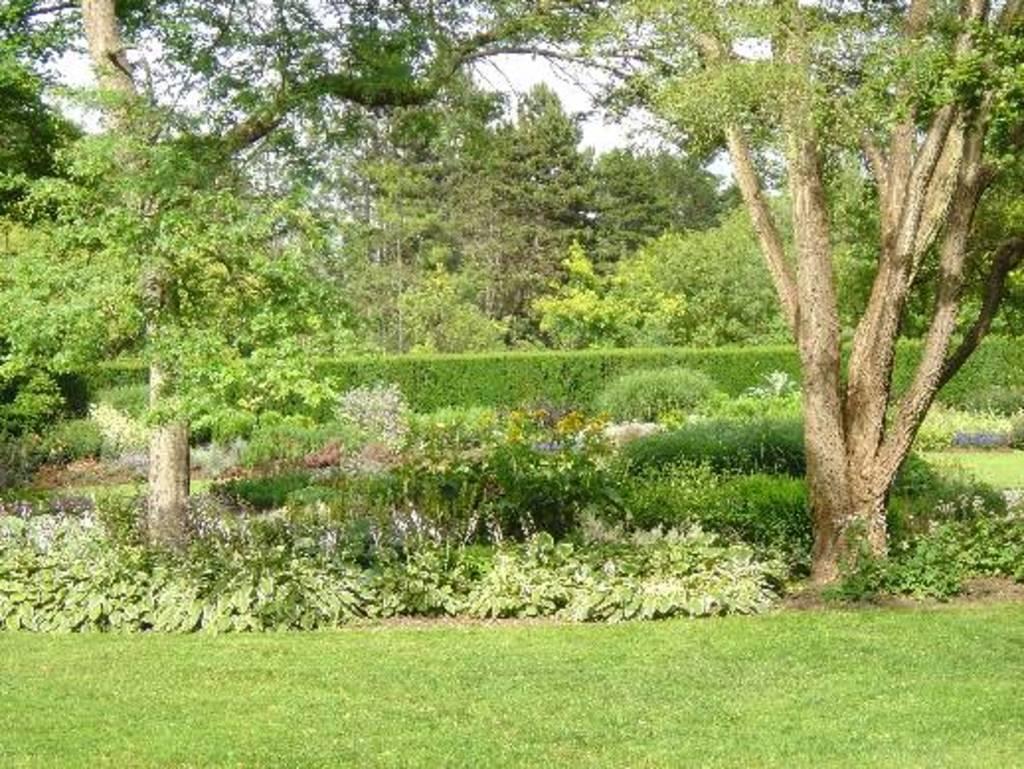Please provide a concise description of this image. This is an outside view. At the bottom of the mage I can see the grass. In the background there are some plants and trees. 